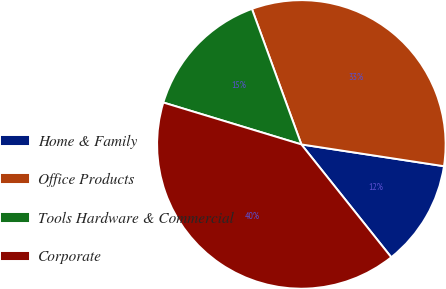Convert chart to OTSL. <chart><loc_0><loc_0><loc_500><loc_500><pie_chart><fcel>Home & Family<fcel>Office Products<fcel>Tools Hardware & Commercial<fcel>Corporate<nl><fcel>11.88%<fcel>32.98%<fcel>14.74%<fcel>40.4%<nl></chart> 